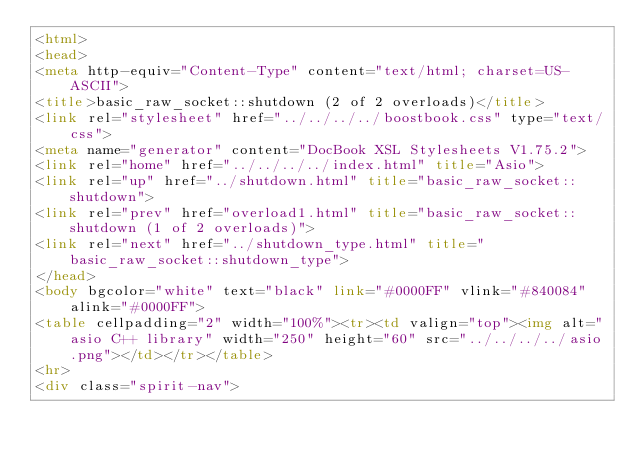Convert code to text. <code><loc_0><loc_0><loc_500><loc_500><_HTML_><html>
<head>
<meta http-equiv="Content-Type" content="text/html; charset=US-ASCII">
<title>basic_raw_socket::shutdown (2 of 2 overloads)</title>
<link rel="stylesheet" href="../../../../boostbook.css" type="text/css">
<meta name="generator" content="DocBook XSL Stylesheets V1.75.2">
<link rel="home" href="../../../../index.html" title="Asio">
<link rel="up" href="../shutdown.html" title="basic_raw_socket::shutdown">
<link rel="prev" href="overload1.html" title="basic_raw_socket::shutdown (1 of 2 overloads)">
<link rel="next" href="../shutdown_type.html" title="basic_raw_socket::shutdown_type">
</head>
<body bgcolor="white" text="black" link="#0000FF" vlink="#840084" alink="#0000FF">
<table cellpadding="2" width="100%"><tr><td valign="top"><img alt="asio C++ library" width="250" height="60" src="../../../../asio.png"></td></tr></table>
<hr>
<div class="spirit-nav"></code> 